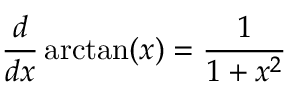Convert formula to latex. <formula><loc_0><loc_0><loc_500><loc_500>{ \frac { d } { d x } } \arctan ( x ) = { \frac { 1 } { 1 + x ^ { 2 } } }</formula> 